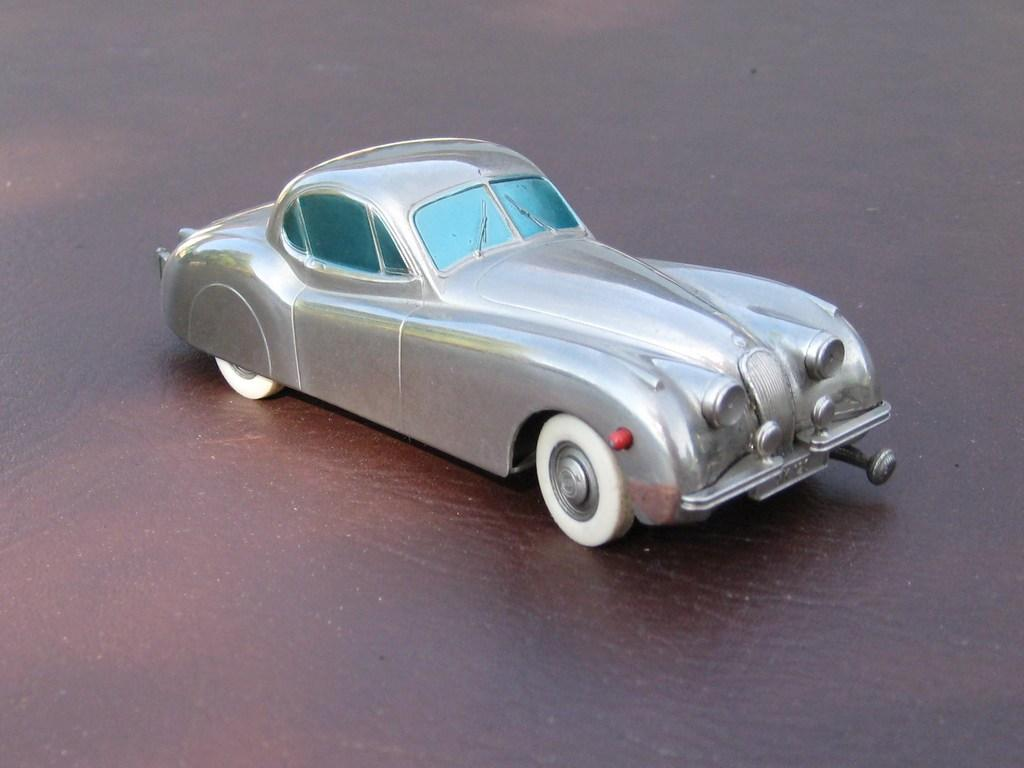What is the main subject in the center of the image? There is a toy car in the center of the image. Where is the toy car located? The toy car is on the floor. What type of disease is the toy car suffering from in the image? The toy car is not a living organism and therefore cannot suffer from any disease. 